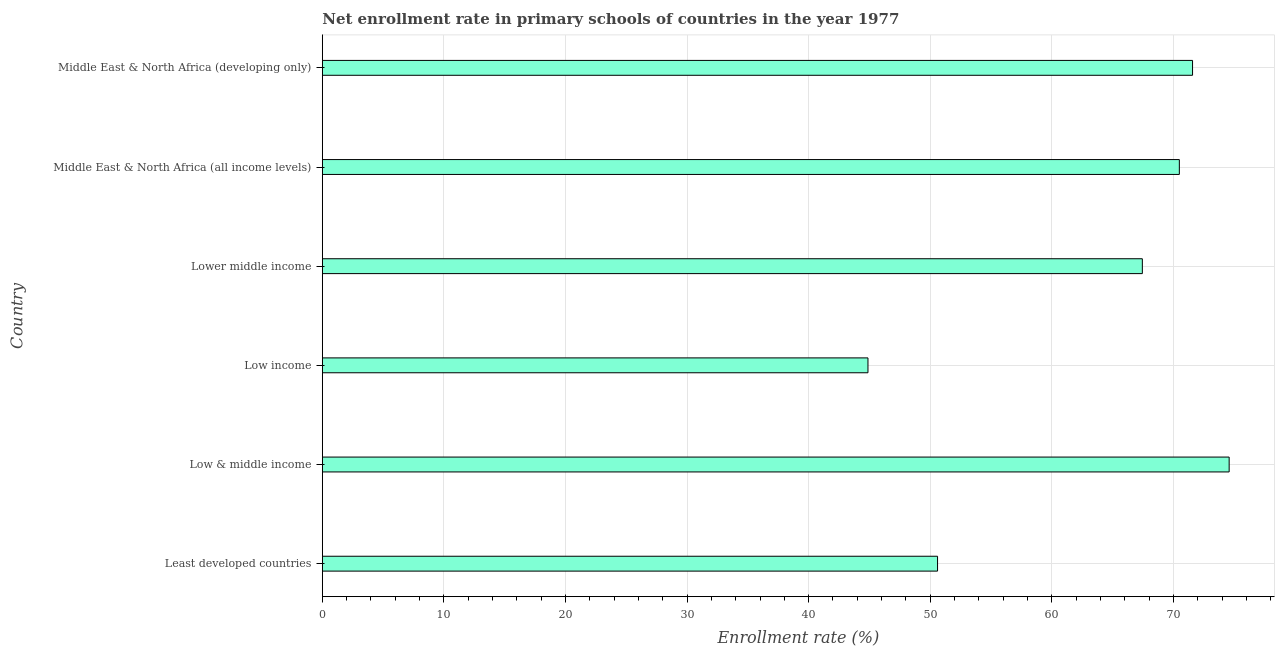What is the title of the graph?
Provide a short and direct response. Net enrollment rate in primary schools of countries in the year 1977. What is the label or title of the X-axis?
Keep it short and to the point. Enrollment rate (%). What is the net enrollment rate in primary schools in Middle East & North Africa (developing only)?
Ensure brevity in your answer.  71.58. Across all countries, what is the maximum net enrollment rate in primary schools?
Keep it short and to the point. 74.59. Across all countries, what is the minimum net enrollment rate in primary schools?
Offer a very short reply. 44.88. In which country was the net enrollment rate in primary schools maximum?
Offer a very short reply. Low & middle income. What is the sum of the net enrollment rate in primary schools?
Offer a terse response. 379.58. What is the difference between the net enrollment rate in primary schools in Least developed countries and Middle East & North Africa (developing only)?
Keep it short and to the point. -20.97. What is the average net enrollment rate in primary schools per country?
Provide a succinct answer. 63.26. What is the median net enrollment rate in primary schools?
Your answer should be compact. 68.97. What is the ratio of the net enrollment rate in primary schools in Low income to that in Lower middle income?
Make the answer very short. 0.67. What is the difference between the highest and the second highest net enrollment rate in primary schools?
Your response must be concise. 3.01. What is the difference between the highest and the lowest net enrollment rate in primary schools?
Your response must be concise. 29.71. How many bars are there?
Offer a terse response. 6. Are all the bars in the graph horizontal?
Make the answer very short. Yes. How many countries are there in the graph?
Provide a short and direct response. 6. What is the difference between two consecutive major ticks on the X-axis?
Offer a very short reply. 10. What is the Enrollment rate (%) in Least developed countries?
Offer a very short reply. 50.6. What is the Enrollment rate (%) of Low & middle income?
Make the answer very short. 74.59. What is the Enrollment rate (%) of Low income?
Offer a very short reply. 44.88. What is the Enrollment rate (%) of Lower middle income?
Your answer should be very brief. 67.45. What is the Enrollment rate (%) in Middle East & North Africa (all income levels)?
Give a very brief answer. 70.49. What is the Enrollment rate (%) of Middle East & North Africa (developing only)?
Give a very brief answer. 71.58. What is the difference between the Enrollment rate (%) in Least developed countries and Low & middle income?
Offer a very short reply. -23.98. What is the difference between the Enrollment rate (%) in Least developed countries and Low income?
Your response must be concise. 5.72. What is the difference between the Enrollment rate (%) in Least developed countries and Lower middle income?
Offer a very short reply. -16.84. What is the difference between the Enrollment rate (%) in Least developed countries and Middle East & North Africa (all income levels)?
Your response must be concise. -19.89. What is the difference between the Enrollment rate (%) in Least developed countries and Middle East & North Africa (developing only)?
Offer a very short reply. -20.97. What is the difference between the Enrollment rate (%) in Low & middle income and Low income?
Your answer should be very brief. 29.71. What is the difference between the Enrollment rate (%) in Low & middle income and Lower middle income?
Offer a very short reply. 7.14. What is the difference between the Enrollment rate (%) in Low & middle income and Middle East & North Africa (all income levels)?
Your answer should be compact. 4.1. What is the difference between the Enrollment rate (%) in Low & middle income and Middle East & North Africa (developing only)?
Offer a terse response. 3.01. What is the difference between the Enrollment rate (%) in Low income and Lower middle income?
Offer a terse response. -22.57. What is the difference between the Enrollment rate (%) in Low income and Middle East & North Africa (all income levels)?
Provide a succinct answer. -25.61. What is the difference between the Enrollment rate (%) in Low income and Middle East & North Africa (developing only)?
Provide a succinct answer. -26.7. What is the difference between the Enrollment rate (%) in Lower middle income and Middle East & North Africa (all income levels)?
Offer a very short reply. -3.04. What is the difference between the Enrollment rate (%) in Lower middle income and Middle East & North Africa (developing only)?
Make the answer very short. -4.13. What is the difference between the Enrollment rate (%) in Middle East & North Africa (all income levels) and Middle East & North Africa (developing only)?
Provide a succinct answer. -1.09. What is the ratio of the Enrollment rate (%) in Least developed countries to that in Low & middle income?
Ensure brevity in your answer.  0.68. What is the ratio of the Enrollment rate (%) in Least developed countries to that in Low income?
Give a very brief answer. 1.13. What is the ratio of the Enrollment rate (%) in Least developed countries to that in Middle East & North Africa (all income levels)?
Offer a terse response. 0.72. What is the ratio of the Enrollment rate (%) in Least developed countries to that in Middle East & North Africa (developing only)?
Ensure brevity in your answer.  0.71. What is the ratio of the Enrollment rate (%) in Low & middle income to that in Low income?
Your answer should be compact. 1.66. What is the ratio of the Enrollment rate (%) in Low & middle income to that in Lower middle income?
Your answer should be compact. 1.11. What is the ratio of the Enrollment rate (%) in Low & middle income to that in Middle East & North Africa (all income levels)?
Keep it short and to the point. 1.06. What is the ratio of the Enrollment rate (%) in Low & middle income to that in Middle East & North Africa (developing only)?
Keep it short and to the point. 1.04. What is the ratio of the Enrollment rate (%) in Low income to that in Lower middle income?
Offer a very short reply. 0.67. What is the ratio of the Enrollment rate (%) in Low income to that in Middle East & North Africa (all income levels)?
Your answer should be very brief. 0.64. What is the ratio of the Enrollment rate (%) in Low income to that in Middle East & North Africa (developing only)?
Give a very brief answer. 0.63. What is the ratio of the Enrollment rate (%) in Lower middle income to that in Middle East & North Africa (developing only)?
Keep it short and to the point. 0.94. 